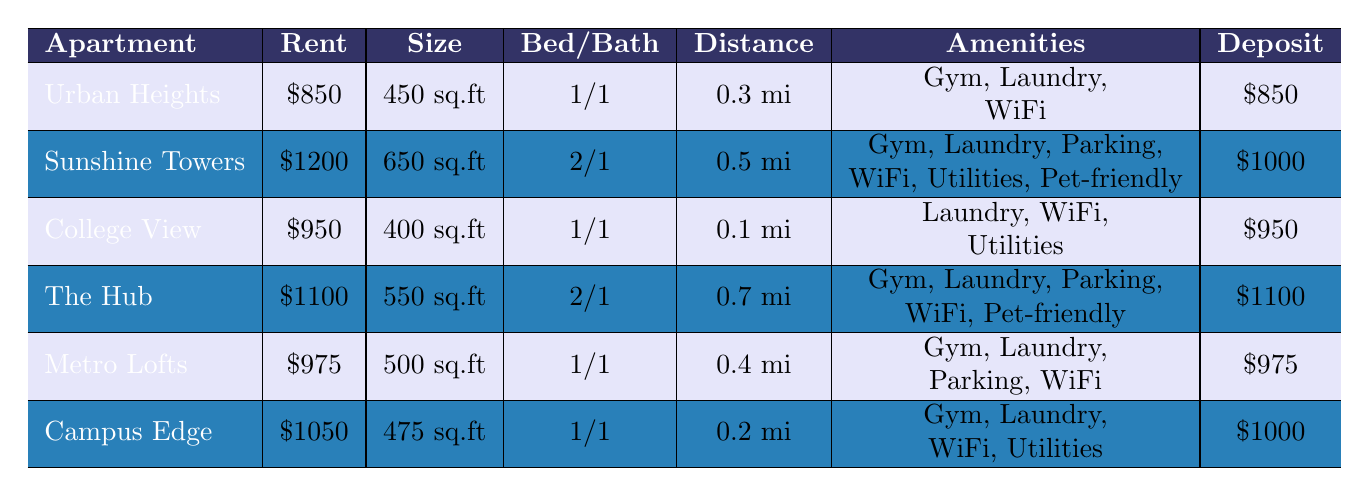What is the cheapest apartment listed? The cheapest apartment is Urban Heights, which has a monthly rent of $850.
Answer: Urban Heights How many apartments have gym facilities? Looking at the table, Urban Heights, Sunshine Towers, The Hub, Metro Lofts, and Campus Edge all have gym facilities. That's a total of 5 apartments.
Answer: 5 What is the total square footage of apartments that are pet-friendly? The total square footage for pet-friendly apartments is calculated as follows: Sunshine Towers (650) + The Hub (550) = 1200 sq.ft.
Answer: 1200 sq.ft Does College View include utilities? Yes, the table indicates that College View includes utilities.
Answer: Yes Which apartment is the farthest from campus? By checking the distance from campus, The Hub is located 0.7 miles away, making it the farthest.
Answer: The Hub What is the average monthly rent of all listed apartments? To find the average, we need to add all the monthly rents and divide by the number of apartments: (850 + 1200 + 950 + 1100 + 975 + 1050) / 6 = 1030.83. So the average monthly rent is approximately $1030.83.
Answer: $1030.83 How many apartments have parking available? Examining the table, only Sunshine Towers, The Hub, and Metro Lofts have parking, totaling 3 apartments.
Answer: 3 Which apartments have both laundry and Wi-Fi? Looking through the entries, all apartments listed (Urban Heights, Sunshine Towers, College View, The Hub, Metro Lofts, Campus Edge) have both laundry and Wi-Fi.
Answer: All apartments What is the security deposit for the most expensive apartment and its name? The most expensive apartment is Sunshine Towers, which has a security deposit of $1000.
Answer: Sunshine Towers, $1000 Which apartment is closest to the campus? College View is 0.1 miles away from campus, making it the closest.
Answer: College View 